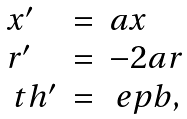<formula> <loc_0><loc_0><loc_500><loc_500>\begin{array} { l l l } x ^ { \prime } & = & a x \\ r ^ { \prime } & = & - 2 a r \\ \ t h ^ { \prime } & = & \ e p b , \end{array}</formula> 